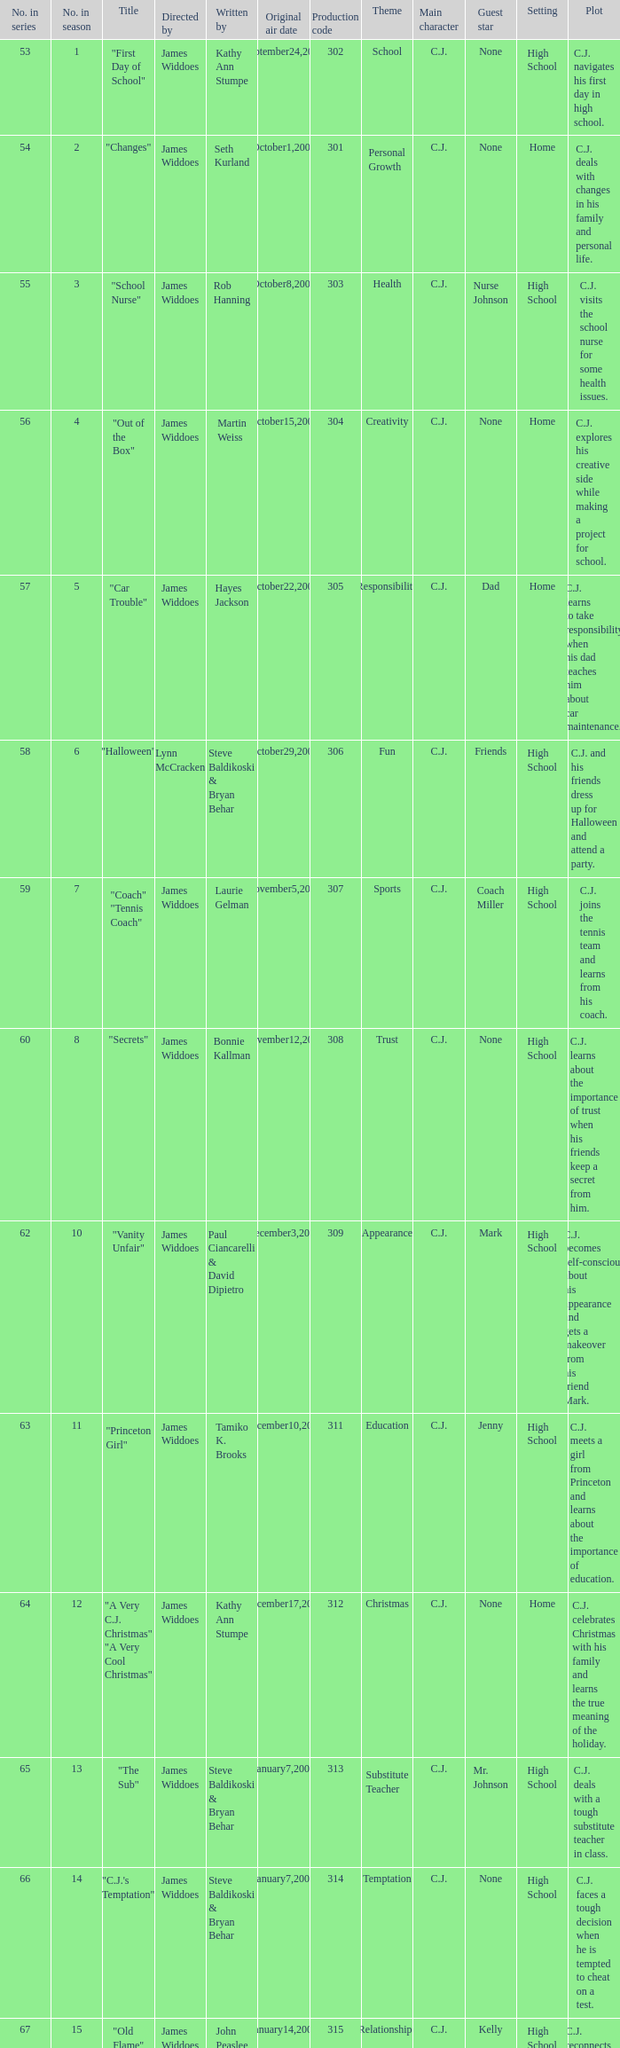Who directed "Freaky Friday"? James Widdoes. 